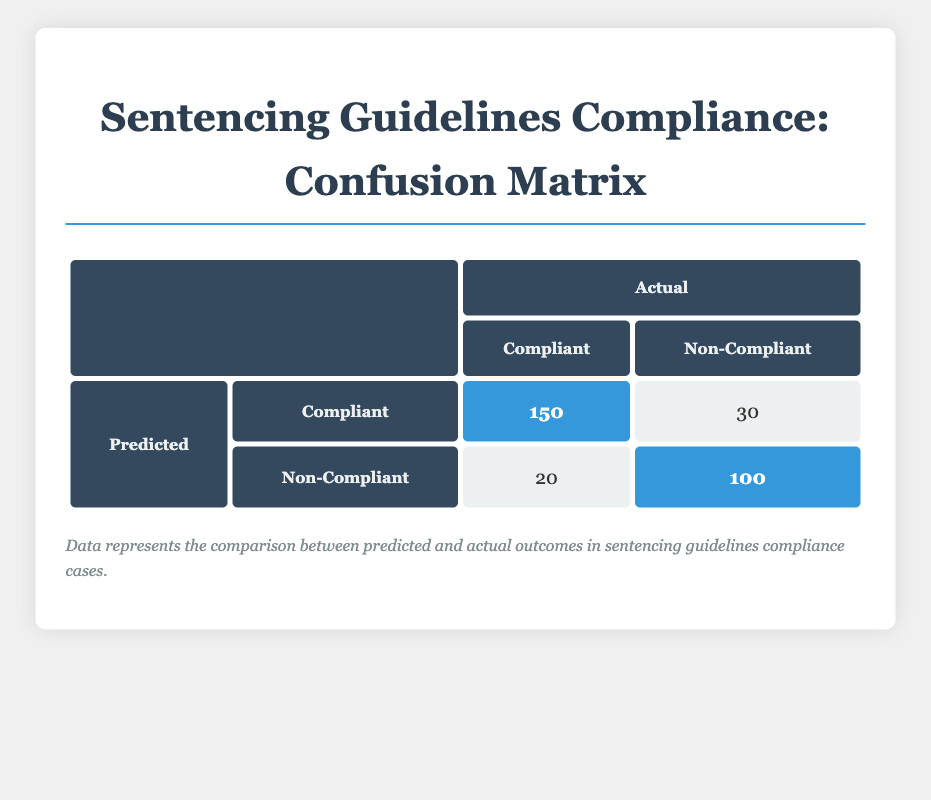How many cases were predicted as Compliant and actually were Compliant? In the table, we look for the cell where "Predicted" is "Compliant" and "Actual" is "Compliant." The count in that cell is 150, representing the cases that were both predicted and actual as compliant.
Answer: 150 What is the total number of Non-Compliant predictions? To find the total number of Non-Compliant predictions, add the counts of the predictions labeled as Non-Compliant: 20 (predicted Non-Compliant and actual Compliant) + 100 (predicted Non-Compliant and actual Non-Compliant) = 120.
Answer: 120 Is it true that there were more cases of actual compliance than non-compliance? To determine this, we compare total counts for each category. The total for Compliant is 150 (predicted Compliant and actual Compliant) + 20 (predicted Non-Compliant and actual Compliant) = 170. The total for Non-Compliant is 30 (predicted Compliant and actual Non-Compliant) + 100 (predicted Non-Compliant and actual Non-Compliant) = 130. Since 170 > 130, the statement is true.
Answer: Yes What percentage of the predicted Compliant cases were actually Compliant? We find the total number of predicted Compliant cases, which is 150 (actual Compliant) + 30 (actual Non-Compliant) = 180. The actual Compliant cases from those predictions are 150. Now, calculating the percentage: (150 / 180) * 100 = 83.33%.
Answer: 83.33% If we consider only the Non-Compliant predictions, what fraction was actually Compliant? From the predictions, the Non-Compliant cases are 20 (predicted Non-Compliant and actual Compliant) + 100 (predicted Non-Compliant and actual Non-Compliant) = 120. The number of those that were actually Compliant is 20. Thus, the fraction is 20 out of 120, which simplifies to 1/6.
Answer: 1/6 How many total cases were analyzed in the confusion matrix? To determine the total number of cases, we sum all counts in the matrix: 150 (Compliant/Compliant) + 30 (Compliant/Non-Compliant) + 20 (Non-Compliant/Compliant) + 100 (Non-Compliant/Non-Compliant) = 300 cases analyzed.
Answer: 300 What is the difference in counts between compliant predictions and non-compliant predictions? We calculate the total for compliant predictions (150 + 30 = 180) and non-compliant predictions (20 + 100 = 120). The difference is 180 (compliant) - 120 (non-compliant) = 60.
Answer: 60 How many cases were incorrectly predicted as Non-Compliant? Incorrectly predicted cases happen when actual cases are Compliant, yet predicted as Non-Compliant. This count is 20.
Answer: 20 